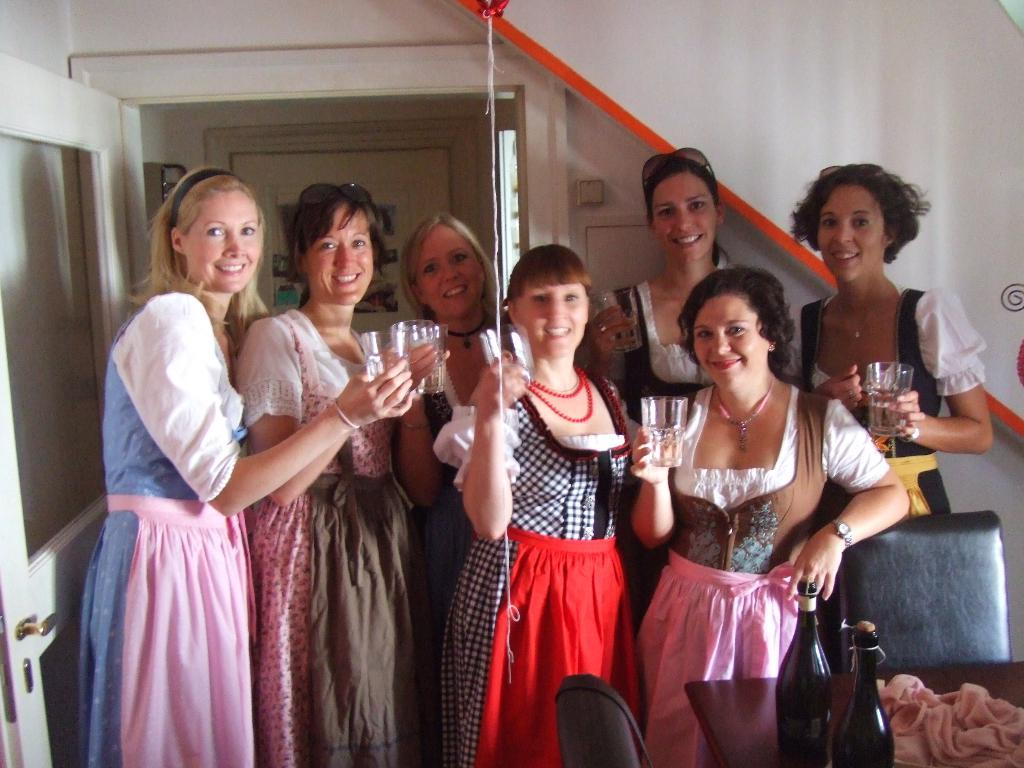What can be seen in the image? There is a group of girls in the image. What are the girls holding in their hands? The girls are holding glasses in their hands. Where are the girls positioned in the image? The girls are standing at the center of the image. What else is visible on the right side of the image? There are bottles on the right side of the image. What is located on the left side of the image? There is a door on the left side of the image. How much tax is being paid by the girls in the image? There is no mention of tax in the image, as it features a group of girls holding glasses and standing at the center of the image. 